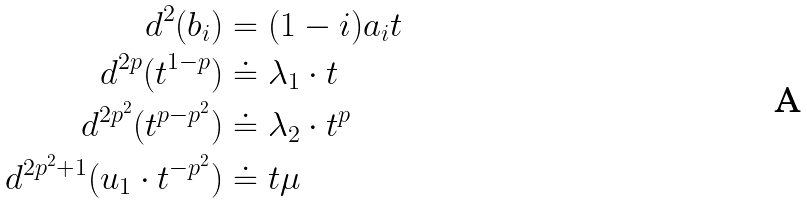<formula> <loc_0><loc_0><loc_500><loc_500>d ^ { 2 } ( b _ { i } ) & = ( 1 - i ) a _ { i } t \\ d ^ { 2 p } ( t ^ { 1 - p } ) & \doteq \lambda _ { 1 } \cdot t \\ d ^ { 2 p ^ { 2 } } ( t ^ { p - p ^ { 2 } } ) & \doteq \lambda _ { 2 } \cdot t ^ { p } \\ d ^ { 2 p ^ { 2 } + 1 } ( u _ { 1 } \cdot t ^ { - p ^ { 2 } } ) & \doteq t \mu</formula> 